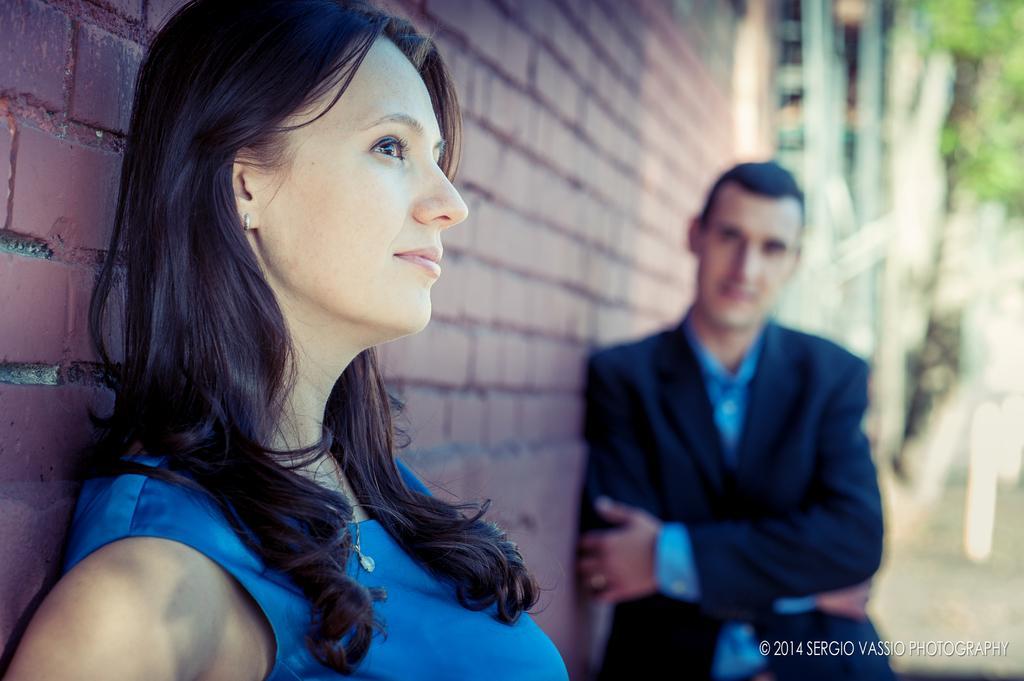Describe this image in one or two sentences. This image is taken outdoors. In the background there is a wall and there is a tree. There are a few objects. On the left side of the image a woman is standing. On the right side of the image a man is standing. 